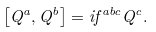Convert formula to latex. <formula><loc_0><loc_0><loc_500><loc_500>\left [ Q ^ { a } , Q ^ { b } \right ] = i f ^ { a b c } Q ^ { c } .</formula> 